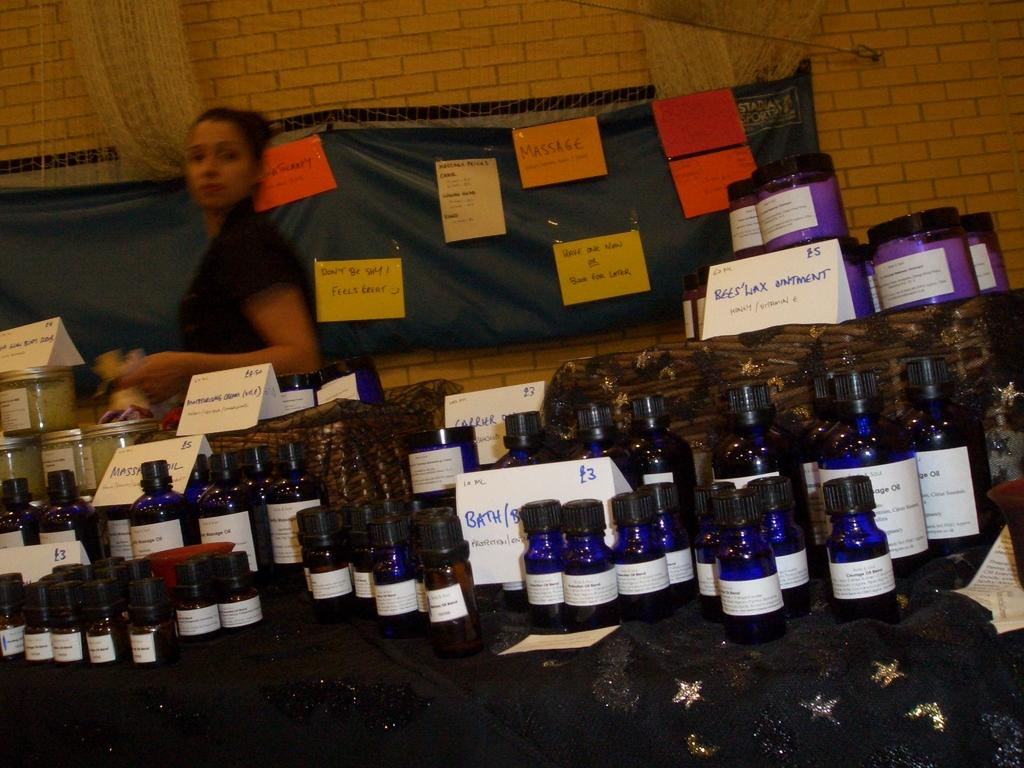<image>
Share a concise interpretation of the image provided. A woman stands behind a table with many bottles for sale, including Beeswax Ointment and Moisturizing Cream. 